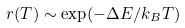<formula> <loc_0><loc_0><loc_500><loc_500>r ( T ) \sim \exp ( - \Delta E / k _ { B } T )</formula> 